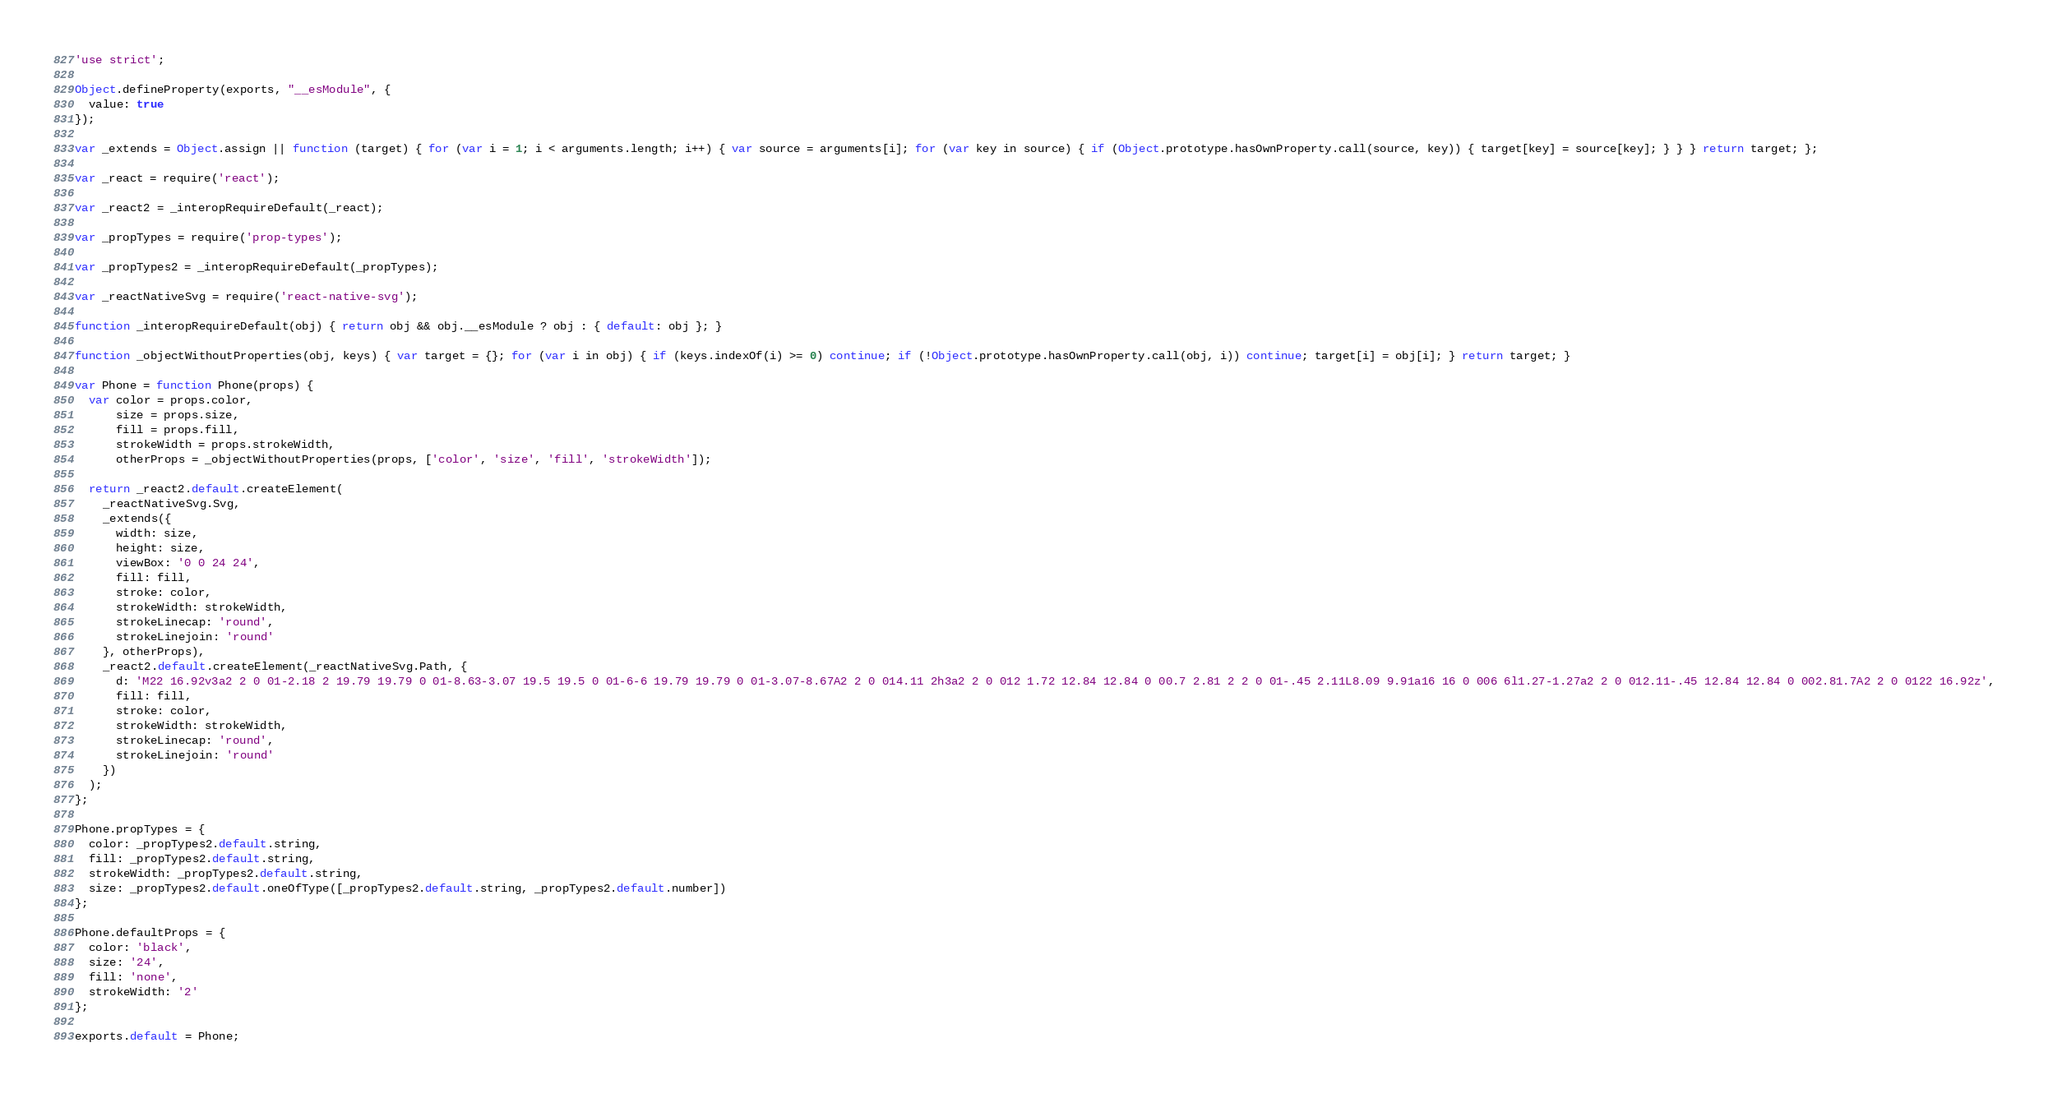<code> <loc_0><loc_0><loc_500><loc_500><_JavaScript_>'use strict';

Object.defineProperty(exports, "__esModule", {
  value: true
});

var _extends = Object.assign || function (target) { for (var i = 1; i < arguments.length; i++) { var source = arguments[i]; for (var key in source) { if (Object.prototype.hasOwnProperty.call(source, key)) { target[key] = source[key]; } } } return target; };

var _react = require('react');

var _react2 = _interopRequireDefault(_react);

var _propTypes = require('prop-types');

var _propTypes2 = _interopRequireDefault(_propTypes);

var _reactNativeSvg = require('react-native-svg');

function _interopRequireDefault(obj) { return obj && obj.__esModule ? obj : { default: obj }; }

function _objectWithoutProperties(obj, keys) { var target = {}; for (var i in obj) { if (keys.indexOf(i) >= 0) continue; if (!Object.prototype.hasOwnProperty.call(obj, i)) continue; target[i] = obj[i]; } return target; }

var Phone = function Phone(props) {
  var color = props.color,
      size = props.size,
      fill = props.fill,
      strokeWidth = props.strokeWidth,
      otherProps = _objectWithoutProperties(props, ['color', 'size', 'fill', 'strokeWidth']);

  return _react2.default.createElement(
    _reactNativeSvg.Svg,
    _extends({
      width: size,
      height: size,
      viewBox: '0 0 24 24',
      fill: fill,
      stroke: color,
      strokeWidth: strokeWidth,
      strokeLinecap: 'round',
      strokeLinejoin: 'round'
    }, otherProps),
    _react2.default.createElement(_reactNativeSvg.Path, {
      d: 'M22 16.92v3a2 2 0 01-2.18 2 19.79 19.79 0 01-8.63-3.07 19.5 19.5 0 01-6-6 19.79 19.79 0 01-3.07-8.67A2 2 0 014.11 2h3a2 2 0 012 1.72 12.84 12.84 0 00.7 2.81 2 2 0 01-.45 2.11L8.09 9.91a16 16 0 006 6l1.27-1.27a2 2 0 012.11-.45 12.84 12.84 0 002.81.7A2 2 0 0122 16.92z',
      fill: fill,
      stroke: color,
      strokeWidth: strokeWidth,
      strokeLinecap: 'round',
      strokeLinejoin: 'round'
    })
  );
};

Phone.propTypes = {
  color: _propTypes2.default.string,
  fill: _propTypes2.default.string,
  strokeWidth: _propTypes2.default.string,
  size: _propTypes2.default.oneOfType([_propTypes2.default.string, _propTypes2.default.number])
};

Phone.defaultProps = {
  color: 'black',
  size: '24',
  fill: 'none',
  strokeWidth: '2'
};

exports.default = Phone;</code> 